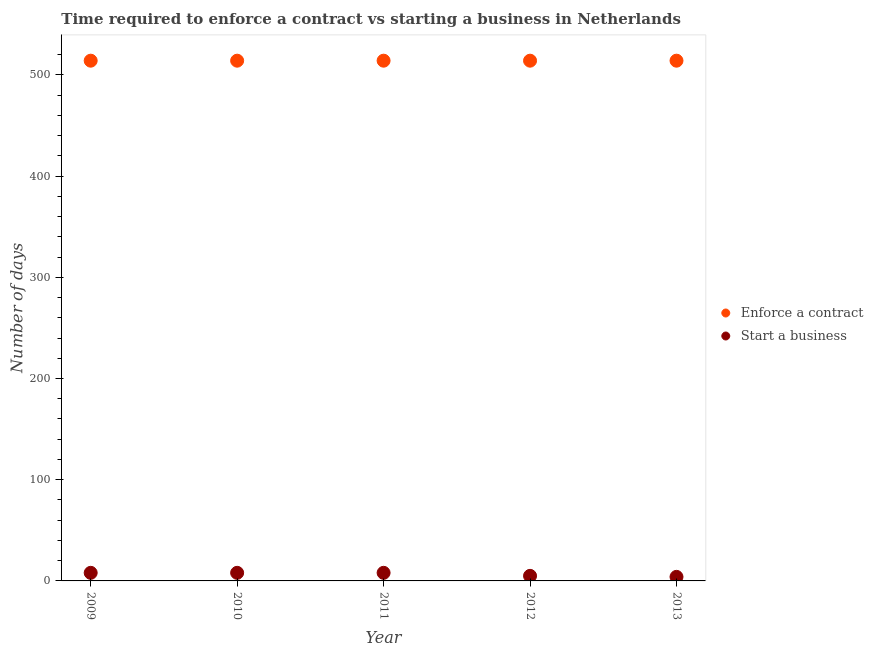Is the number of dotlines equal to the number of legend labels?
Give a very brief answer. Yes. What is the number of days to enforece a contract in 2012?
Give a very brief answer. 514. Across all years, what is the maximum number of days to enforece a contract?
Your answer should be very brief. 514. Across all years, what is the minimum number of days to start a business?
Your response must be concise. 4. In which year was the number of days to enforece a contract maximum?
Offer a terse response. 2009. In which year was the number of days to enforece a contract minimum?
Offer a terse response. 2009. What is the total number of days to enforece a contract in the graph?
Ensure brevity in your answer.  2570. What is the difference between the number of days to enforece a contract in 2012 and that in 2013?
Your answer should be compact. 0. What is the difference between the number of days to enforece a contract in 2010 and the number of days to start a business in 2009?
Your response must be concise. 506. What is the average number of days to enforece a contract per year?
Keep it short and to the point. 514. In the year 2013, what is the difference between the number of days to enforece a contract and number of days to start a business?
Give a very brief answer. 510. In how many years, is the number of days to enforece a contract greater than 240 days?
Your answer should be compact. 5. Is the number of days to start a business in 2010 less than that in 2011?
Keep it short and to the point. No. Is the difference between the number of days to start a business in 2009 and 2010 greater than the difference between the number of days to enforece a contract in 2009 and 2010?
Make the answer very short. No. What is the difference between the highest and the lowest number of days to enforece a contract?
Ensure brevity in your answer.  0. In how many years, is the number of days to enforece a contract greater than the average number of days to enforece a contract taken over all years?
Provide a short and direct response. 0. Is the number of days to start a business strictly greater than the number of days to enforece a contract over the years?
Give a very brief answer. No. How many dotlines are there?
Your answer should be very brief. 2. How many years are there in the graph?
Provide a short and direct response. 5. Are the values on the major ticks of Y-axis written in scientific E-notation?
Ensure brevity in your answer.  No. Does the graph contain grids?
Your response must be concise. No. How many legend labels are there?
Keep it short and to the point. 2. What is the title of the graph?
Offer a terse response. Time required to enforce a contract vs starting a business in Netherlands. What is the label or title of the Y-axis?
Provide a succinct answer. Number of days. What is the Number of days in Enforce a contract in 2009?
Your answer should be very brief. 514. What is the Number of days in Start a business in 2009?
Keep it short and to the point. 8. What is the Number of days in Enforce a contract in 2010?
Provide a short and direct response. 514. What is the Number of days in Start a business in 2010?
Give a very brief answer. 8. What is the Number of days in Enforce a contract in 2011?
Make the answer very short. 514. What is the Number of days in Enforce a contract in 2012?
Your answer should be compact. 514. What is the Number of days of Enforce a contract in 2013?
Provide a short and direct response. 514. Across all years, what is the maximum Number of days of Enforce a contract?
Keep it short and to the point. 514. Across all years, what is the maximum Number of days in Start a business?
Give a very brief answer. 8. Across all years, what is the minimum Number of days in Enforce a contract?
Your answer should be very brief. 514. Across all years, what is the minimum Number of days in Start a business?
Provide a short and direct response. 4. What is the total Number of days in Enforce a contract in the graph?
Your answer should be compact. 2570. What is the total Number of days of Start a business in the graph?
Your answer should be compact. 33. What is the difference between the Number of days in Enforce a contract in 2009 and that in 2010?
Your answer should be compact. 0. What is the difference between the Number of days of Start a business in 2009 and that in 2011?
Your answer should be very brief. 0. What is the difference between the Number of days of Enforce a contract in 2009 and that in 2012?
Your answer should be very brief. 0. What is the difference between the Number of days of Start a business in 2009 and that in 2012?
Provide a succinct answer. 3. What is the difference between the Number of days of Enforce a contract in 2009 and that in 2013?
Give a very brief answer. 0. What is the difference between the Number of days in Start a business in 2009 and that in 2013?
Provide a short and direct response. 4. What is the difference between the Number of days of Enforce a contract in 2010 and that in 2011?
Ensure brevity in your answer.  0. What is the difference between the Number of days in Start a business in 2010 and that in 2011?
Provide a succinct answer. 0. What is the difference between the Number of days in Enforce a contract in 2010 and that in 2012?
Ensure brevity in your answer.  0. What is the difference between the Number of days of Start a business in 2010 and that in 2012?
Provide a short and direct response. 3. What is the difference between the Number of days in Enforce a contract in 2010 and that in 2013?
Keep it short and to the point. 0. What is the difference between the Number of days of Start a business in 2011 and that in 2013?
Provide a short and direct response. 4. What is the difference between the Number of days of Enforce a contract in 2012 and that in 2013?
Give a very brief answer. 0. What is the difference between the Number of days of Enforce a contract in 2009 and the Number of days of Start a business in 2010?
Your answer should be very brief. 506. What is the difference between the Number of days of Enforce a contract in 2009 and the Number of days of Start a business in 2011?
Provide a succinct answer. 506. What is the difference between the Number of days of Enforce a contract in 2009 and the Number of days of Start a business in 2012?
Provide a succinct answer. 509. What is the difference between the Number of days of Enforce a contract in 2009 and the Number of days of Start a business in 2013?
Keep it short and to the point. 510. What is the difference between the Number of days in Enforce a contract in 2010 and the Number of days in Start a business in 2011?
Ensure brevity in your answer.  506. What is the difference between the Number of days in Enforce a contract in 2010 and the Number of days in Start a business in 2012?
Provide a short and direct response. 509. What is the difference between the Number of days of Enforce a contract in 2010 and the Number of days of Start a business in 2013?
Ensure brevity in your answer.  510. What is the difference between the Number of days in Enforce a contract in 2011 and the Number of days in Start a business in 2012?
Keep it short and to the point. 509. What is the difference between the Number of days in Enforce a contract in 2011 and the Number of days in Start a business in 2013?
Ensure brevity in your answer.  510. What is the difference between the Number of days in Enforce a contract in 2012 and the Number of days in Start a business in 2013?
Ensure brevity in your answer.  510. What is the average Number of days in Enforce a contract per year?
Keep it short and to the point. 514. In the year 2009, what is the difference between the Number of days in Enforce a contract and Number of days in Start a business?
Provide a short and direct response. 506. In the year 2010, what is the difference between the Number of days in Enforce a contract and Number of days in Start a business?
Your response must be concise. 506. In the year 2011, what is the difference between the Number of days of Enforce a contract and Number of days of Start a business?
Make the answer very short. 506. In the year 2012, what is the difference between the Number of days of Enforce a contract and Number of days of Start a business?
Make the answer very short. 509. In the year 2013, what is the difference between the Number of days in Enforce a contract and Number of days in Start a business?
Offer a very short reply. 510. What is the ratio of the Number of days of Enforce a contract in 2009 to that in 2011?
Your response must be concise. 1. What is the ratio of the Number of days in Enforce a contract in 2009 to that in 2012?
Make the answer very short. 1. What is the ratio of the Number of days of Start a business in 2009 to that in 2012?
Your answer should be very brief. 1.6. What is the ratio of the Number of days of Enforce a contract in 2009 to that in 2013?
Offer a very short reply. 1. What is the ratio of the Number of days in Start a business in 2009 to that in 2013?
Make the answer very short. 2. What is the ratio of the Number of days of Enforce a contract in 2010 to that in 2011?
Offer a terse response. 1. What is the ratio of the Number of days of Start a business in 2010 to that in 2011?
Provide a succinct answer. 1. What is the ratio of the Number of days of Enforce a contract in 2011 to that in 2012?
Your answer should be very brief. 1. What is the ratio of the Number of days of Start a business in 2011 to that in 2012?
Your answer should be compact. 1.6. What is the ratio of the Number of days of Enforce a contract in 2011 to that in 2013?
Your answer should be compact. 1. What is the ratio of the Number of days of Start a business in 2011 to that in 2013?
Provide a succinct answer. 2. What is the ratio of the Number of days of Enforce a contract in 2012 to that in 2013?
Provide a succinct answer. 1. What is the difference between the highest and the second highest Number of days of Start a business?
Provide a succinct answer. 0. What is the difference between the highest and the lowest Number of days of Enforce a contract?
Your answer should be very brief. 0. What is the difference between the highest and the lowest Number of days of Start a business?
Provide a succinct answer. 4. 